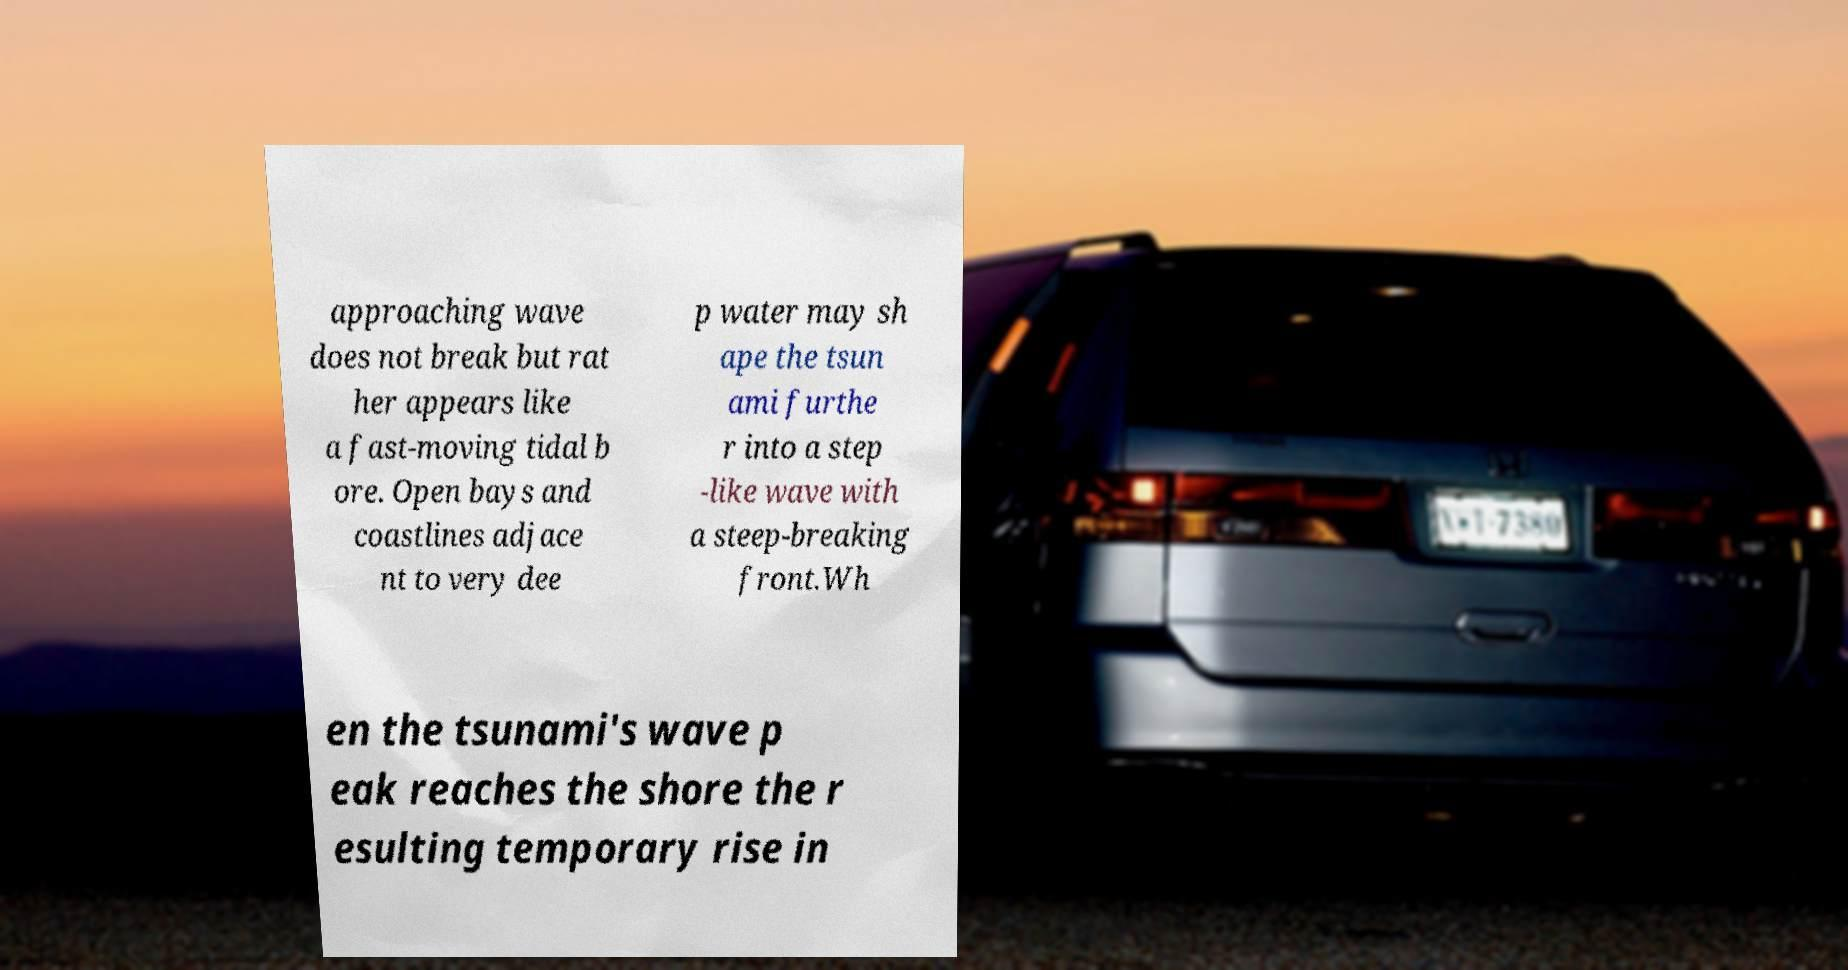There's text embedded in this image that I need extracted. Can you transcribe it verbatim? approaching wave does not break but rat her appears like a fast-moving tidal b ore. Open bays and coastlines adjace nt to very dee p water may sh ape the tsun ami furthe r into a step -like wave with a steep-breaking front.Wh en the tsunami's wave p eak reaches the shore the r esulting temporary rise in 